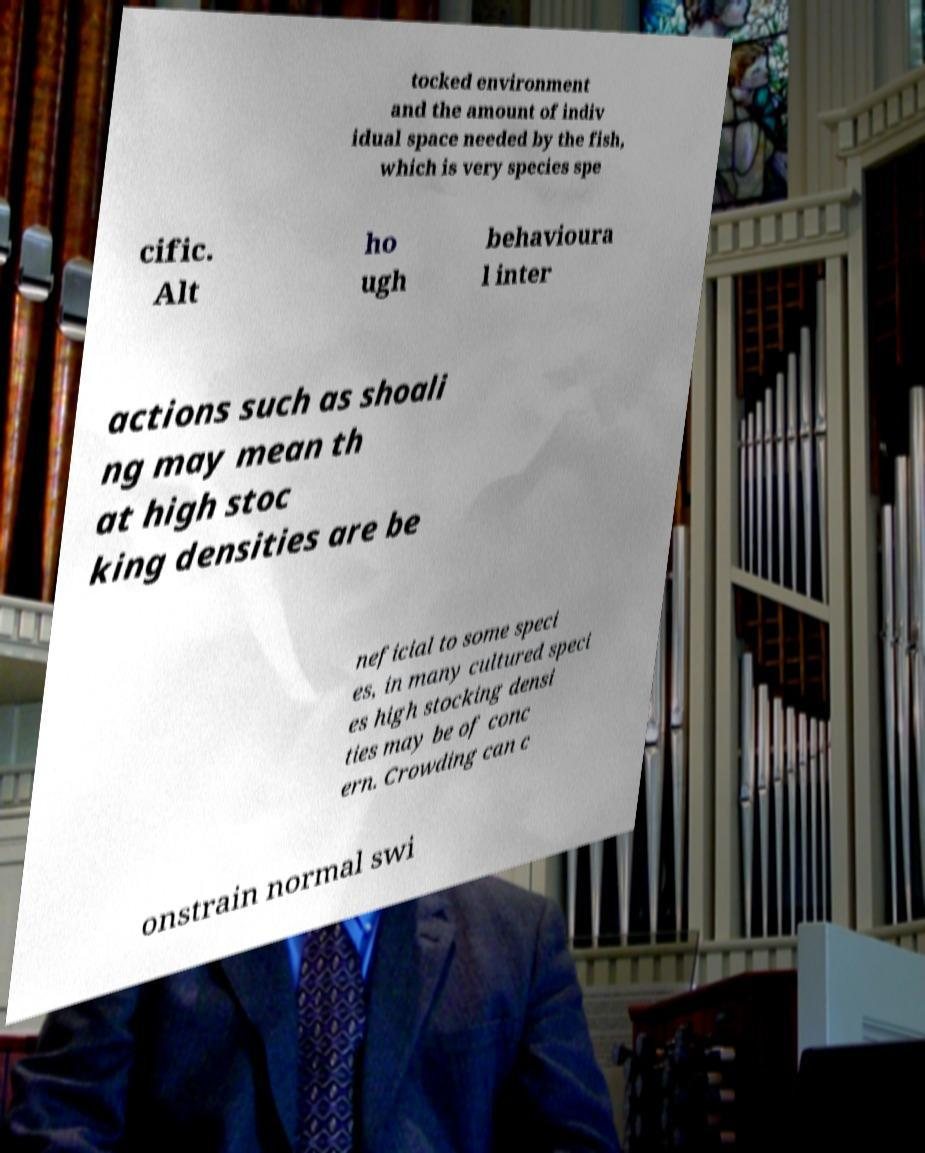Can you accurately transcribe the text from the provided image for me? tocked environment and the amount of indiv idual space needed by the fish, which is very species spe cific. Alt ho ugh behavioura l inter actions such as shoali ng may mean th at high stoc king densities are be neficial to some speci es, in many cultured speci es high stocking densi ties may be of conc ern. Crowding can c onstrain normal swi 